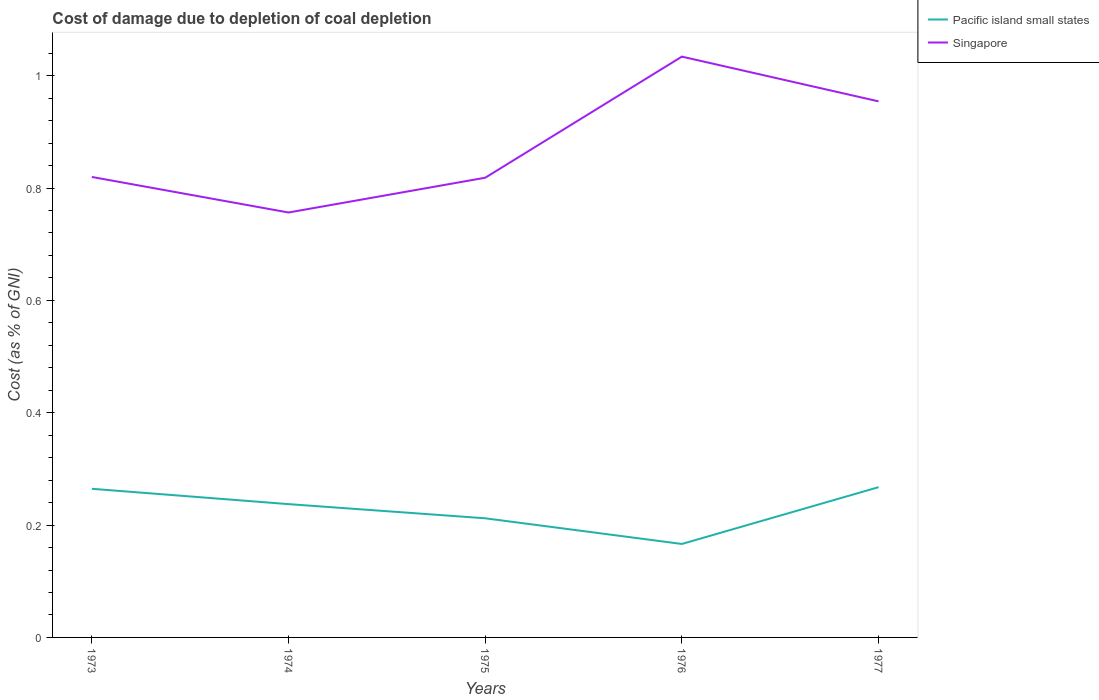Does the line corresponding to Pacific island small states intersect with the line corresponding to Singapore?
Your answer should be very brief. No. Is the number of lines equal to the number of legend labels?
Your answer should be compact. Yes. Across all years, what is the maximum cost of damage caused due to coal depletion in Pacific island small states?
Keep it short and to the point. 0.17. In which year was the cost of damage caused due to coal depletion in Pacific island small states maximum?
Your answer should be compact. 1976. What is the total cost of damage caused due to coal depletion in Pacific island small states in the graph?
Ensure brevity in your answer.  0.03. What is the difference between the highest and the second highest cost of damage caused due to coal depletion in Singapore?
Provide a short and direct response. 0.28. What is the difference between the highest and the lowest cost of damage caused due to coal depletion in Singapore?
Provide a succinct answer. 2. Are the values on the major ticks of Y-axis written in scientific E-notation?
Ensure brevity in your answer.  No. Does the graph contain any zero values?
Offer a terse response. No. Does the graph contain grids?
Keep it short and to the point. No. How are the legend labels stacked?
Provide a short and direct response. Vertical. What is the title of the graph?
Make the answer very short. Cost of damage due to depletion of coal depletion. Does "Solomon Islands" appear as one of the legend labels in the graph?
Make the answer very short. No. What is the label or title of the X-axis?
Your answer should be very brief. Years. What is the label or title of the Y-axis?
Ensure brevity in your answer.  Cost (as % of GNI). What is the Cost (as % of GNI) of Pacific island small states in 1973?
Make the answer very short. 0.26. What is the Cost (as % of GNI) in Singapore in 1973?
Provide a succinct answer. 0.82. What is the Cost (as % of GNI) in Pacific island small states in 1974?
Provide a short and direct response. 0.24. What is the Cost (as % of GNI) of Singapore in 1974?
Your answer should be compact. 0.76. What is the Cost (as % of GNI) of Pacific island small states in 1975?
Provide a succinct answer. 0.21. What is the Cost (as % of GNI) in Singapore in 1975?
Your response must be concise. 0.82. What is the Cost (as % of GNI) of Pacific island small states in 1976?
Make the answer very short. 0.17. What is the Cost (as % of GNI) in Singapore in 1976?
Provide a short and direct response. 1.03. What is the Cost (as % of GNI) in Pacific island small states in 1977?
Offer a terse response. 0.27. What is the Cost (as % of GNI) of Singapore in 1977?
Ensure brevity in your answer.  0.95. Across all years, what is the maximum Cost (as % of GNI) in Pacific island small states?
Offer a very short reply. 0.27. Across all years, what is the maximum Cost (as % of GNI) in Singapore?
Offer a very short reply. 1.03. Across all years, what is the minimum Cost (as % of GNI) of Pacific island small states?
Offer a very short reply. 0.17. Across all years, what is the minimum Cost (as % of GNI) of Singapore?
Your response must be concise. 0.76. What is the total Cost (as % of GNI) in Pacific island small states in the graph?
Give a very brief answer. 1.15. What is the total Cost (as % of GNI) of Singapore in the graph?
Make the answer very short. 4.38. What is the difference between the Cost (as % of GNI) in Pacific island small states in 1973 and that in 1974?
Your answer should be compact. 0.03. What is the difference between the Cost (as % of GNI) of Singapore in 1973 and that in 1974?
Keep it short and to the point. 0.06. What is the difference between the Cost (as % of GNI) in Pacific island small states in 1973 and that in 1975?
Offer a very short reply. 0.05. What is the difference between the Cost (as % of GNI) of Singapore in 1973 and that in 1975?
Your response must be concise. 0. What is the difference between the Cost (as % of GNI) of Pacific island small states in 1973 and that in 1976?
Provide a succinct answer. 0.1. What is the difference between the Cost (as % of GNI) of Singapore in 1973 and that in 1976?
Make the answer very short. -0.21. What is the difference between the Cost (as % of GNI) in Pacific island small states in 1973 and that in 1977?
Provide a short and direct response. -0. What is the difference between the Cost (as % of GNI) of Singapore in 1973 and that in 1977?
Offer a terse response. -0.13. What is the difference between the Cost (as % of GNI) in Pacific island small states in 1974 and that in 1975?
Provide a succinct answer. 0.03. What is the difference between the Cost (as % of GNI) of Singapore in 1974 and that in 1975?
Provide a succinct answer. -0.06. What is the difference between the Cost (as % of GNI) in Pacific island small states in 1974 and that in 1976?
Provide a short and direct response. 0.07. What is the difference between the Cost (as % of GNI) in Singapore in 1974 and that in 1976?
Keep it short and to the point. -0.28. What is the difference between the Cost (as % of GNI) in Pacific island small states in 1974 and that in 1977?
Provide a succinct answer. -0.03. What is the difference between the Cost (as % of GNI) of Singapore in 1974 and that in 1977?
Ensure brevity in your answer.  -0.2. What is the difference between the Cost (as % of GNI) in Pacific island small states in 1975 and that in 1976?
Provide a short and direct response. 0.05. What is the difference between the Cost (as % of GNI) in Singapore in 1975 and that in 1976?
Offer a terse response. -0.22. What is the difference between the Cost (as % of GNI) of Pacific island small states in 1975 and that in 1977?
Ensure brevity in your answer.  -0.06. What is the difference between the Cost (as % of GNI) of Singapore in 1975 and that in 1977?
Your answer should be very brief. -0.14. What is the difference between the Cost (as % of GNI) in Pacific island small states in 1976 and that in 1977?
Your answer should be compact. -0.1. What is the difference between the Cost (as % of GNI) of Singapore in 1976 and that in 1977?
Provide a succinct answer. 0.08. What is the difference between the Cost (as % of GNI) in Pacific island small states in 1973 and the Cost (as % of GNI) in Singapore in 1974?
Your response must be concise. -0.49. What is the difference between the Cost (as % of GNI) of Pacific island small states in 1973 and the Cost (as % of GNI) of Singapore in 1975?
Make the answer very short. -0.55. What is the difference between the Cost (as % of GNI) of Pacific island small states in 1973 and the Cost (as % of GNI) of Singapore in 1976?
Your answer should be very brief. -0.77. What is the difference between the Cost (as % of GNI) of Pacific island small states in 1973 and the Cost (as % of GNI) of Singapore in 1977?
Offer a very short reply. -0.69. What is the difference between the Cost (as % of GNI) in Pacific island small states in 1974 and the Cost (as % of GNI) in Singapore in 1975?
Provide a short and direct response. -0.58. What is the difference between the Cost (as % of GNI) in Pacific island small states in 1974 and the Cost (as % of GNI) in Singapore in 1976?
Keep it short and to the point. -0.8. What is the difference between the Cost (as % of GNI) in Pacific island small states in 1974 and the Cost (as % of GNI) in Singapore in 1977?
Your answer should be very brief. -0.72. What is the difference between the Cost (as % of GNI) of Pacific island small states in 1975 and the Cost (as % of GNI) of Singapore in 1976?
Ensure brevity in your answer.  -0.82. What is the difference between the Cost (as % of GNI) of Pacific island small states in 1975 and the Cost (as % of GNI) of Singapore in 1977?
Your response must be concise. -0.74. What is the difference between the Cost (as % of GNI) of Pacific island small states in 1976 and the Cost (as % of GNI) of Singapore in 1977?
Offer a very short reply. -0.79. What is the average Cost (as % of GNI) of Pacific island small states per year?
Provide a succinct answer. 0.23. What is the average Cost (as % of GNI) in Singapore per year?
Your answer should be compact. 0.88. In the year 1973, what is the difference between the Cost (as % of GNI) of Pacific island small states and Cost (as % of GNI) of Singapore?
Your response must be concise. -0.56. In the year 1974, what is the difference between the Cost (as % of GNI) of Pacific island small states and Cost (as % of GNI) of Singapore?
Your answer should be very brief. -0.52. In the year 1975, what is the difference between the Cost (as % of GNI) of Pacific island small states and Cost (as % of GNI) of Singapore?
Provide a short and direct response. -0.61. In the year 1976, what is the difference between the Cost (as % of GNI) in Pacific island small states and Cost (as % of GNI) in Singapore?
Your answer should be very brief. -0.87. In the year 1977, what is the difference between the Cost (as % of GNI) in Pacific island small states and Cost (as % of GNI) in Singapore?
Offer a terse response. -0.69. What is the ratio of the Cost (as % of GNI) in Pacific island small states in 1973 to that in 1974?
Give a very brief answer. 1.12. What is the ratio of the Cost (as % of GNI) of Singapore in 1973 to that in 1974?
Provide a short and direct response. 1.08. What is the ratio of the Cost (as % of GNI) in Pacific island small states in 1973 to that in 1975?
Keep it short and to the point. 1.25. What is the ratio of the Cost (as % of GNI) of Pacific island small states in 1973 to that in 1976?
Ensure brevity in your answer.  1.59. What is the ratio of the Cost (as % of GNI) of Singapore in 1973 to that in 1976?
Give a very brief answer. 0.79. What is the ratio of the Cost (as % of GNI) of Pacific island small states in 1973 to that in 1977?
Ensure brevity in your answer.  0.99. What is the ratio of the Cost (as % of GNI) in Singapore in 1973 to that in 1977?
Offer a terse response. 0.86. What is the ratio of the Cost (as % of GNI) in Pacific island small states in 1974 to that in 1975?
Make the answer very short. 1.12. What is the ratio of the Cost (as % of GNI) of Singapore in 1974 to that in 1975?
Keep it short and to the point. 0.92. What is the ratio of the Cost (as % of GNI) in Pacific island small states in 1974 to that in 1976?
Offer a terse response. 1.43. What is the ratio of the Cost (as % of GNI) of Singapore in 1974 to that in 1976?
Provide a short and direct response. 0.73. What is the ratio of the Cost (as % of GNI) of Pacific island small states in 1974 to that in 1977?
Make the answer very short. 0.89. What is the ratio of the Cost (as % of GNI) in Singapore in 1974 to that in 1977?
Your response must be concise. 0.79. What is the ratio of the Cost (as % of GNI) of Pacific island small states in 1975 to that in 1976?
Ensure brevity in your answer.  1.27. What is the ratio of the Cost (as % of GNI) in Singapore in 1975 to that in 1976?
Ensure brevity in your answer.  0.79. What is the ratio of the Cost (as % of GNI) in Pacific island small states in 1975 to that in 1977?
Make the answer very short. 0.79. What is the ratio of the Cost (as % of GNI) in Singapore in 1975 to that in 1977?
Ensure brevity in your answer.  0.86. What is the ratio of the Cost (as % of GNI) in Pacific island small states in 1976 to that in 1977?
Your response must be concise. 0.62. What is the ratio of the Cost (as % of GNI) in Singapore in 1976 to that in 1977?
Ensure brevity in your answer.  1.08. What is the difference between the highest and the second highest Cost (as % of GNI) of Pacific island small states?
Make the answer very short. 0. What is the difference between the highest and the second highest Cost (as % of GNI) of Singapore?
Your answer should be compact. 0.08. What is the difference between the highest and the lowest Cost (as % of GNI) in Pacific island small states?
Offer a very short reply. 0.1. What is the difference between the highest and the lowest Cost (as % of GNI) in Singapore?
Give a very brief answer. 0.28. 